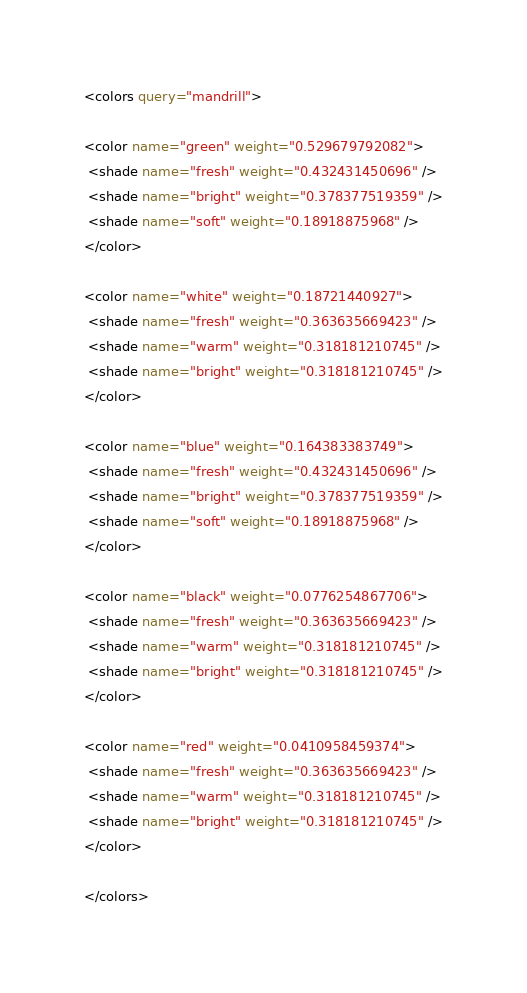<code> <loc_0><loc_0><loc_500><loc_500><_XML_><colors query="mandrill">

<color name="green" weight="0.529679792082">
 <shade name="fresh" weight="0.432431450696" />
 <shade name="bright" weight="0.378377519359" />
 <shade name="soft" weight="0.18918875968" />
</color>

<color name="white" weight="0.18721440927">
 <shade name="fresh" weight="0.363635669423" />
 <shade name="warm" weight="0.318181210745" />
 <shade name="bright" weight="0.318181210745" />
</color>

<color name="blue" weight="0.164383383749">
 <shade name="fresh" weight="0.432431450696" />
 <shade name="bright" weight="0.378377519359" />
 <shade name="soft" weight="0.18918875968" />
</color>

<color name="black" weight="0.0776254867706">
 <shade name="fresh" weight="0.363635669423" />
 <shade name="warm" weight="0.318181210745" />
 <shade name="bright" weight="0.318181210745" />
</color>

<color name="red" weight="0.0410958459374">
 <shade name="fresh" weight="0.363635669423" />
 <shade name="warm" weight="0.318181210745" />
 <shade name="bright" weight="0.318181210745" />
</color>

</colors></code> 